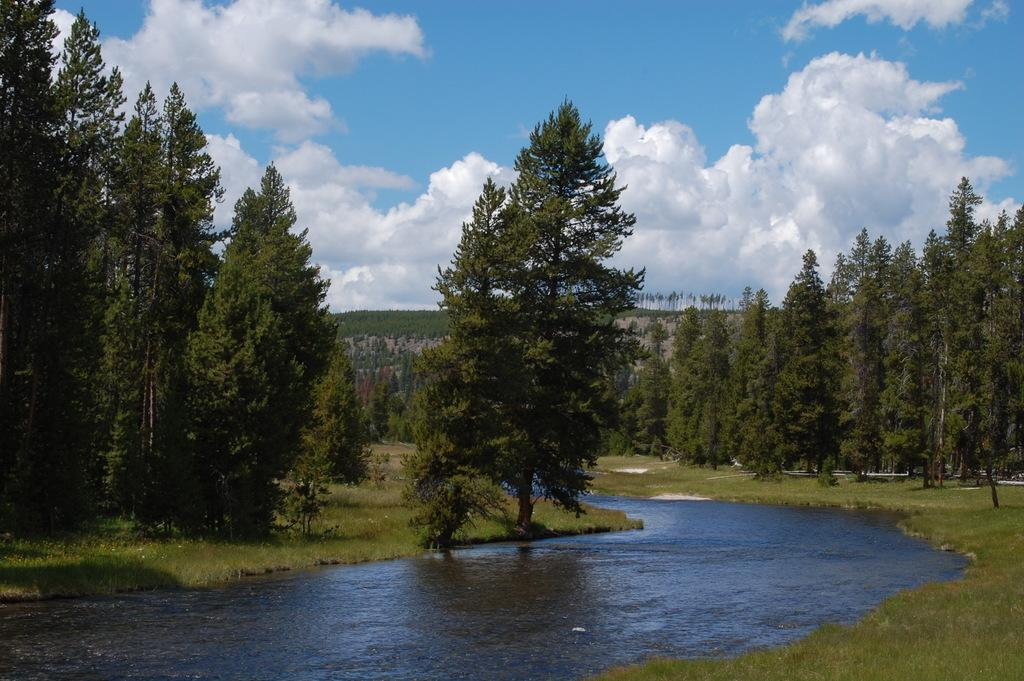What is the main element present in the image? There is water in the image. What type of vegetation can be seen in the image? There are trees in the image. What is at the bottom of the image? There is grass at the bottom of the image. What can be seen in the background of the image? The sky and hills are visible in the background of the image. What is the copper part of the image used for? There is no copper part present in the image. How many minutes does it take for the water to evaporate in the image? The image is a still representation, so it does not show the passage of time or the evaporation of water. 